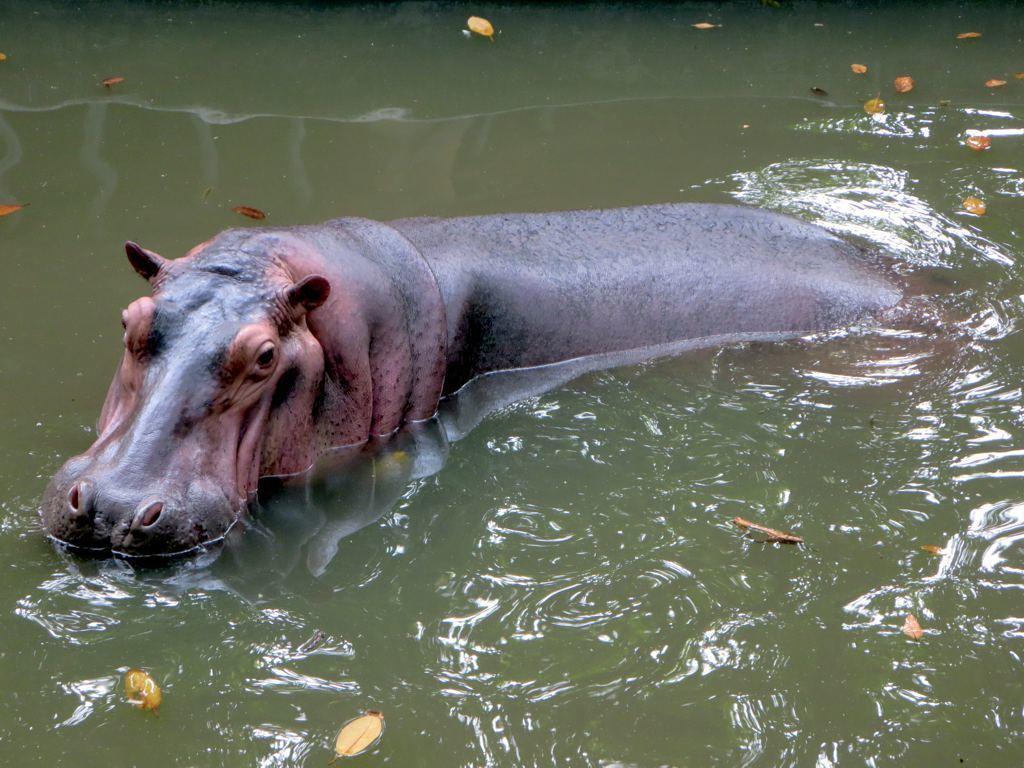Can you describe this image briefly? In the picture we can see a hippopotamus in the water and the water is green in color and with some dried leaves in it. 